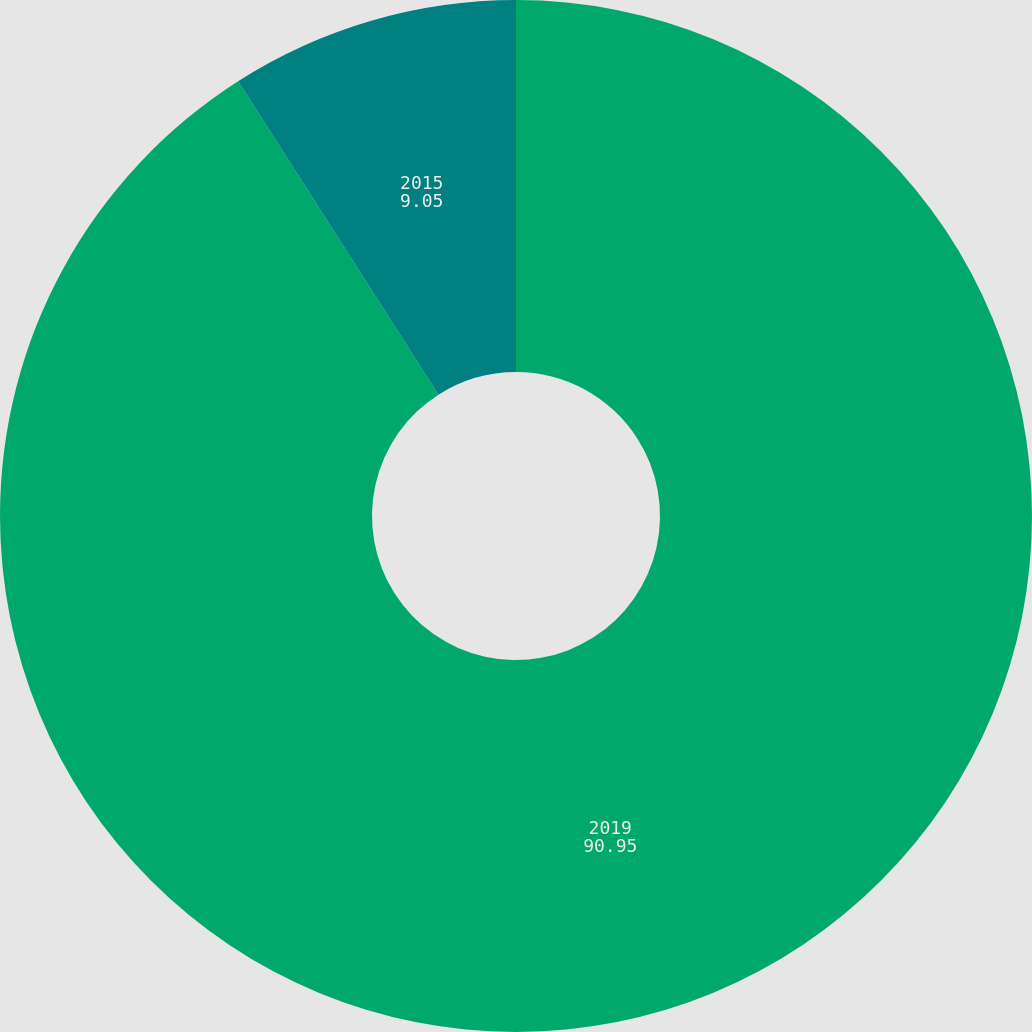Convert chart to OTSL. <chart><loc_0><loc_0><loc_500><loc_500><pie_chart><fcel>2019<fcel>2015<nl><fcel>90.95%<fcel>9.05%<nl></chart> 